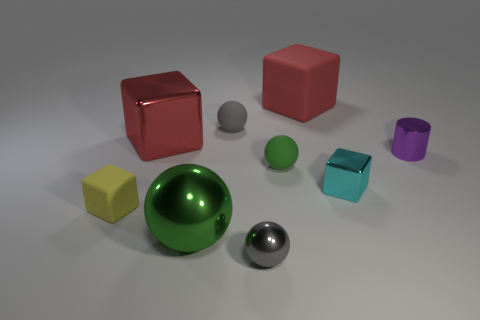Is the color of the large matte object the same as the large shiny block?
Offer a very short reply. Yes. There is a big thing that is behind the red thing in front of the small gray sphere behind the cylinder; what is its shape?
Offer a terse response. Cube. What material is the small green sphere?
Give a very brief answer. Rubber. What is the color of the tiny ball that is the same material as the tiny cylinder?
Provide a succinct answer. Gray. There is a tiny matte thing in front of the small green rubber object; is there a tiny thing in front of it?
Your answer should be compact. Yes. What number of other objects are the same shape as the purple shiny thing?
Make the answer very short. 0. Do the green thing that is behind the tiny cyan metallic thing and the red thing to the left of the small gray metal thing have the same shape?
Your answer should be compact. No. How many red blocks are on the left side of the big object to the right of the green ball that is behind the small yellow rubber thing?
Offer a very short reply. 1. What is the color of the cylinder?
Your answer should be very brief. Purple. How many other objects are there of the same size as the yellow thing?
Offer a terse response. 5. 